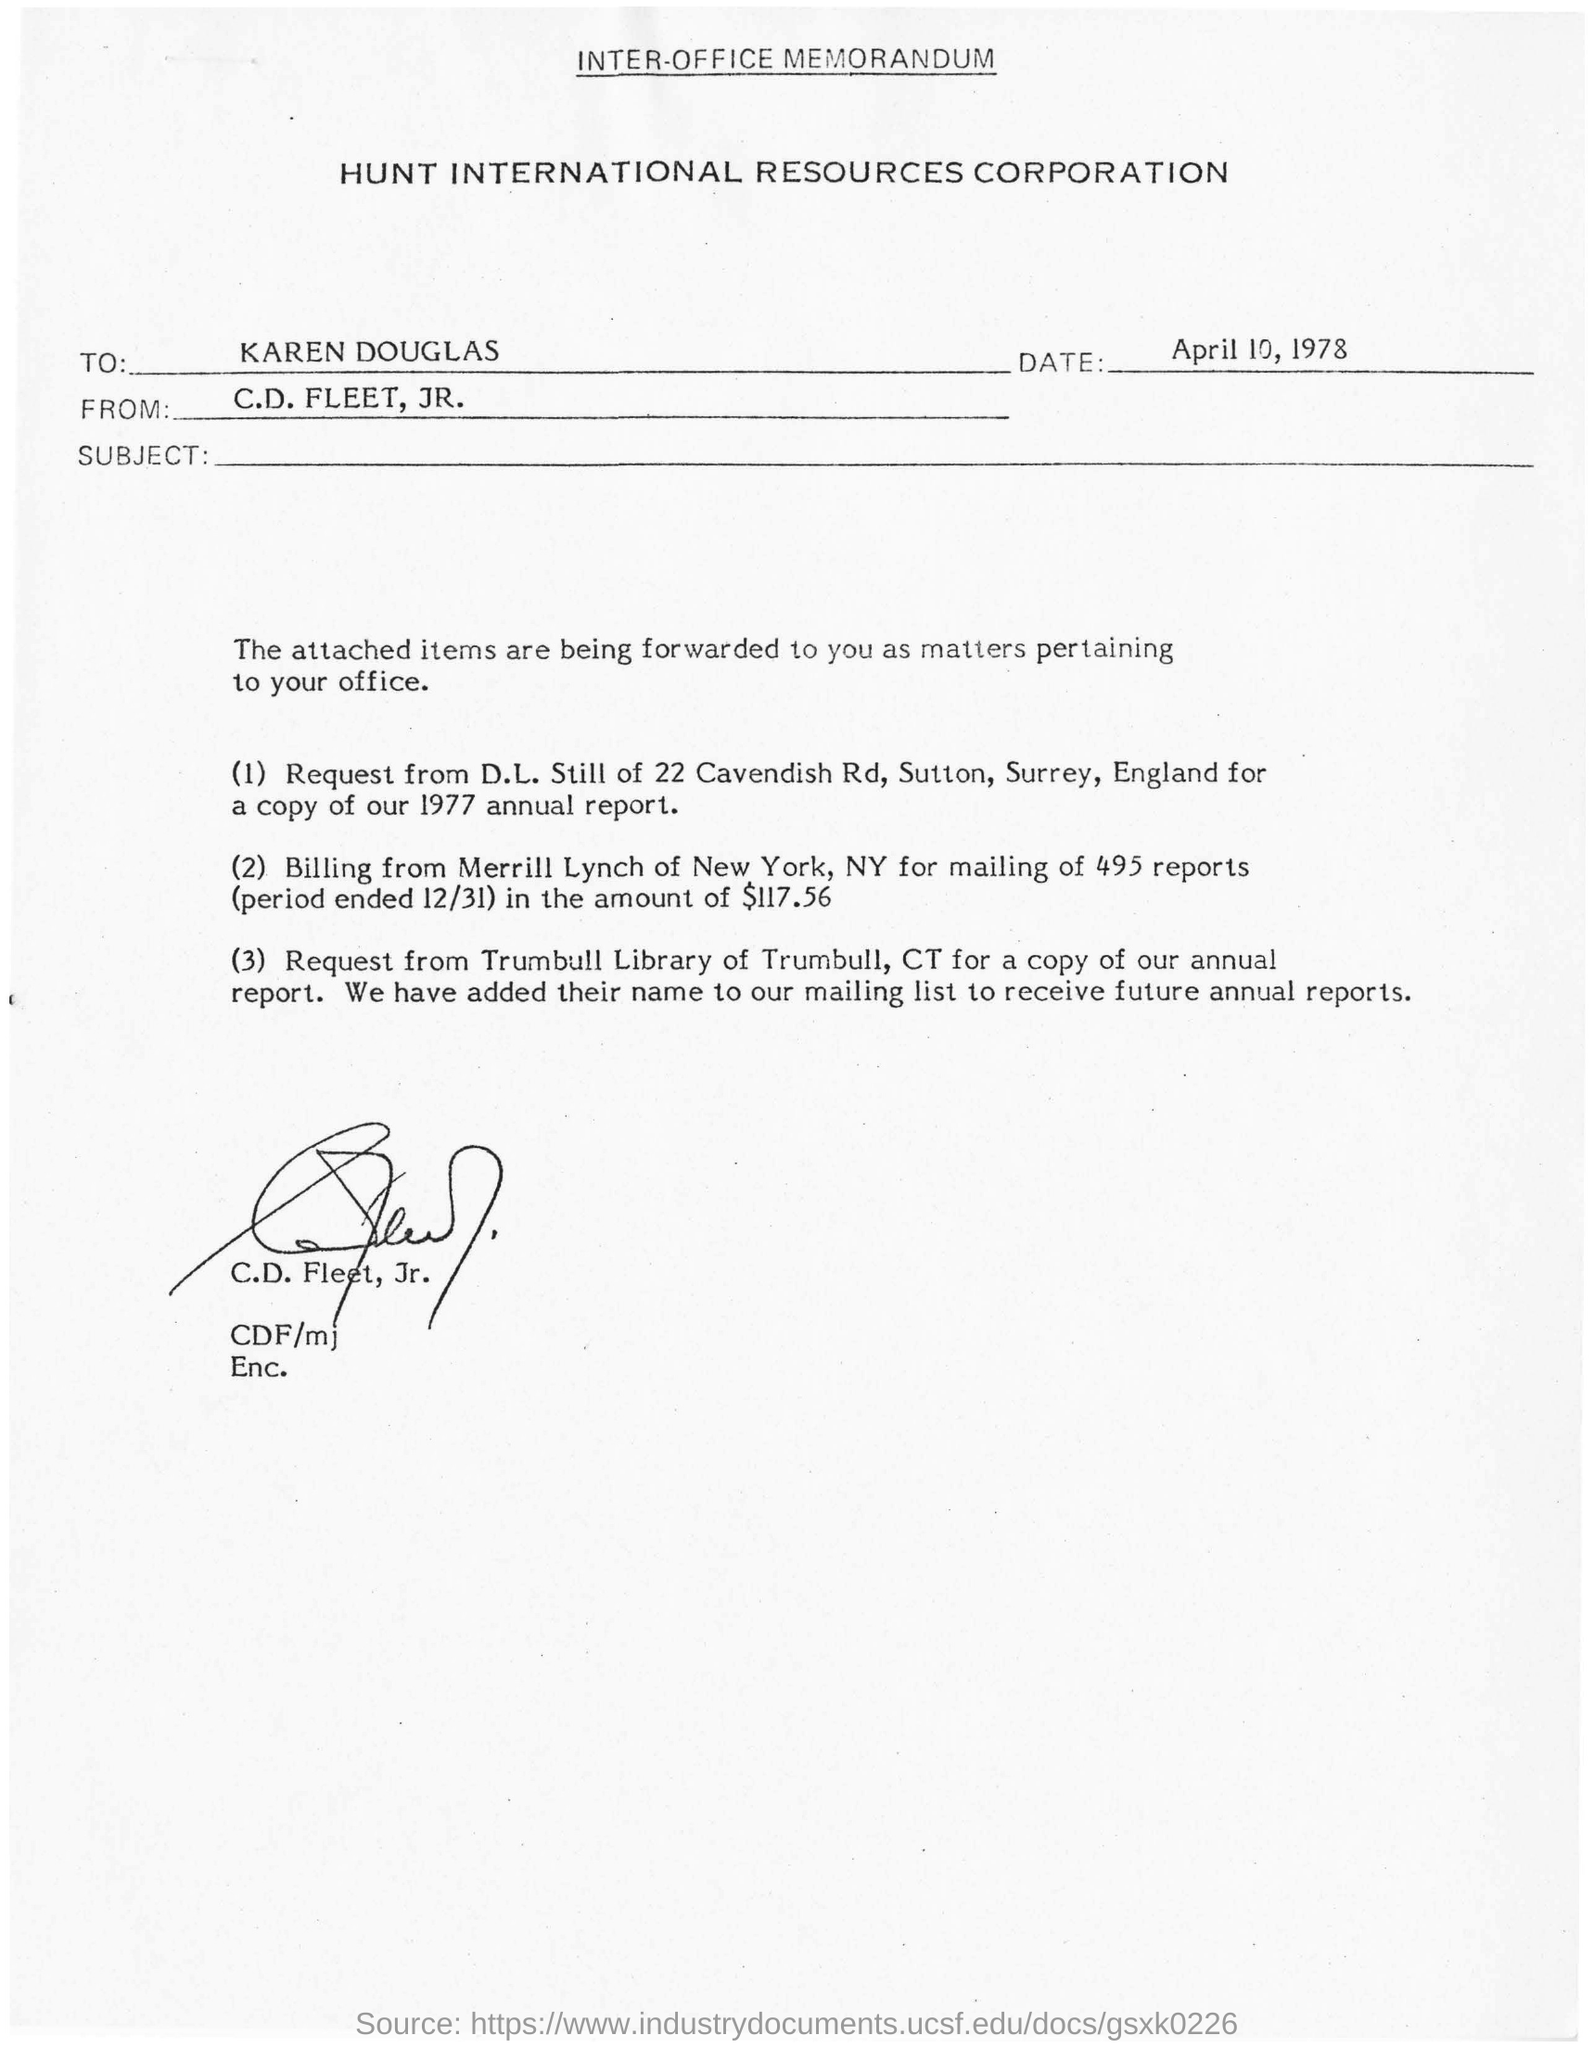Who is the sender of this memorandum?
Ensure brevity in your answer.  C.D. FLEET, JR. By whom has this document been written?
Offer a terse response. C.D. FLEET, JR. What is the date mentioned?
Your answer should be very brief. April 10, 1978. To whom is this document addressed?
Ensure brevity in your answer.  KAREN DOUGLAS. 